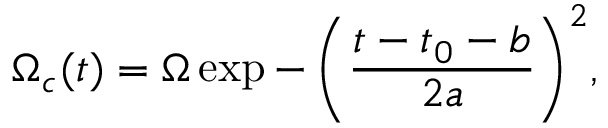Convert formula to latex. <formula><loc_0><loc_0><loc_500><loc_500>\Omega _ { c } ( t ) = \Omega \exp { - \left ( \frac { t - t _ { 0 } - b } { 2 a } \right ) ^ { 2 } } ,</formula> 